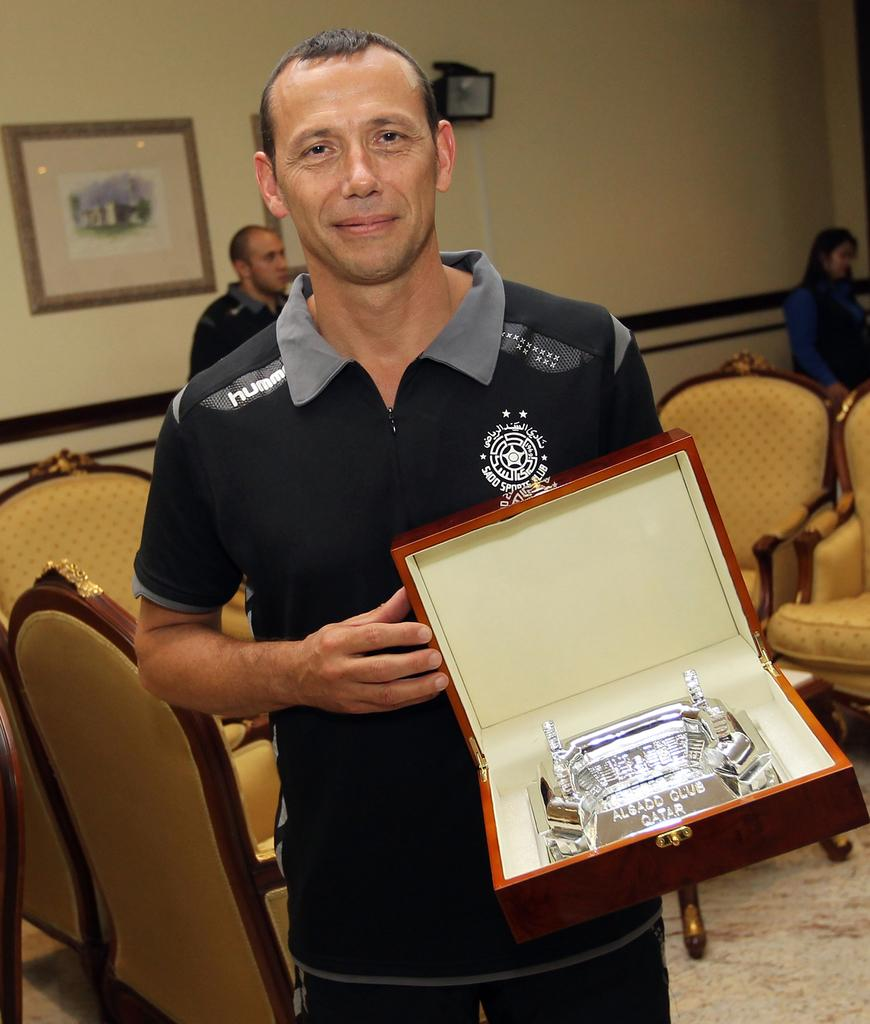What type of structure can be seen in the image? There is a wall in the image. What is hanging on the wall? There is a photo frame in the image. What type of furniture is present in the image? There are chairs in the image. Who is in the image? A man is standing in the image. What is the man holding in the image? The man is holding a box. How does the man's pain manifest in the image? There is no indication of pain in the image; the man is standing and holding a box. What type of queen is depicted in the photo frame in the image? There is no queen depicted in the image; the photo frame contains an unspecified photo. 